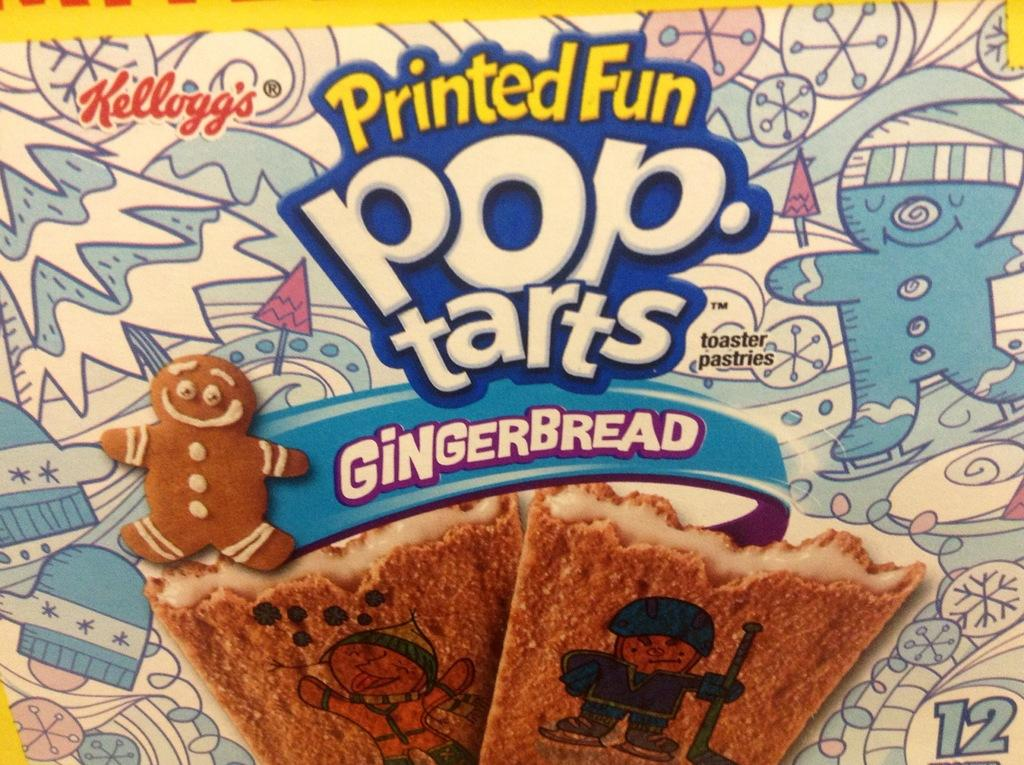What type of food can be seen in the image? The food in the image has brown and cream colors. Can you describe the background of the image? The background of the image is multi-colored. Is there any text or writing visible in the image? Yes, there is text or writing visible in the image. What type of shirt is the beggar wearing in the image? There is no beggar or shirt present in the image. What are the hobbies of the people in the image? The provided facts do not mention any people or their hobbies in the image. 